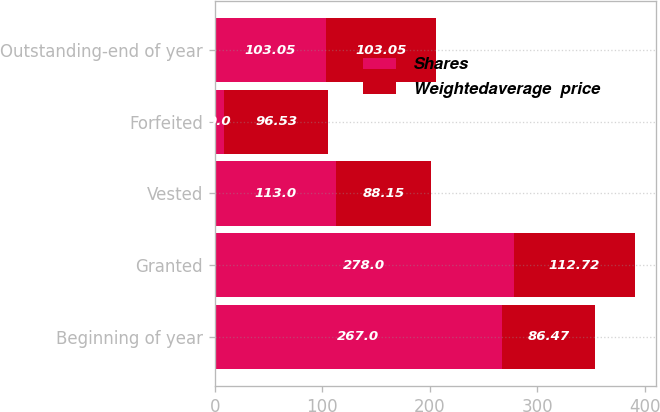<chart> <loc_0><loc_0><loc_500><loc_500><stacked_bar_chart><ecel><fcel>Beginning of year<fcel>Granted<fcel>Vested<fcel>Forfeited<fcel>Outstanding-end of year<nl><fcel>Shares<fcel>267<fcel>278<fcel>113<fcel>9<fcel>103.05<nl><fcel>Weightedaverage  price<fcel>86.47<fcel>112.72<fcel>88.15<fcel>96.53<fcel>103.05<nl></chart> 